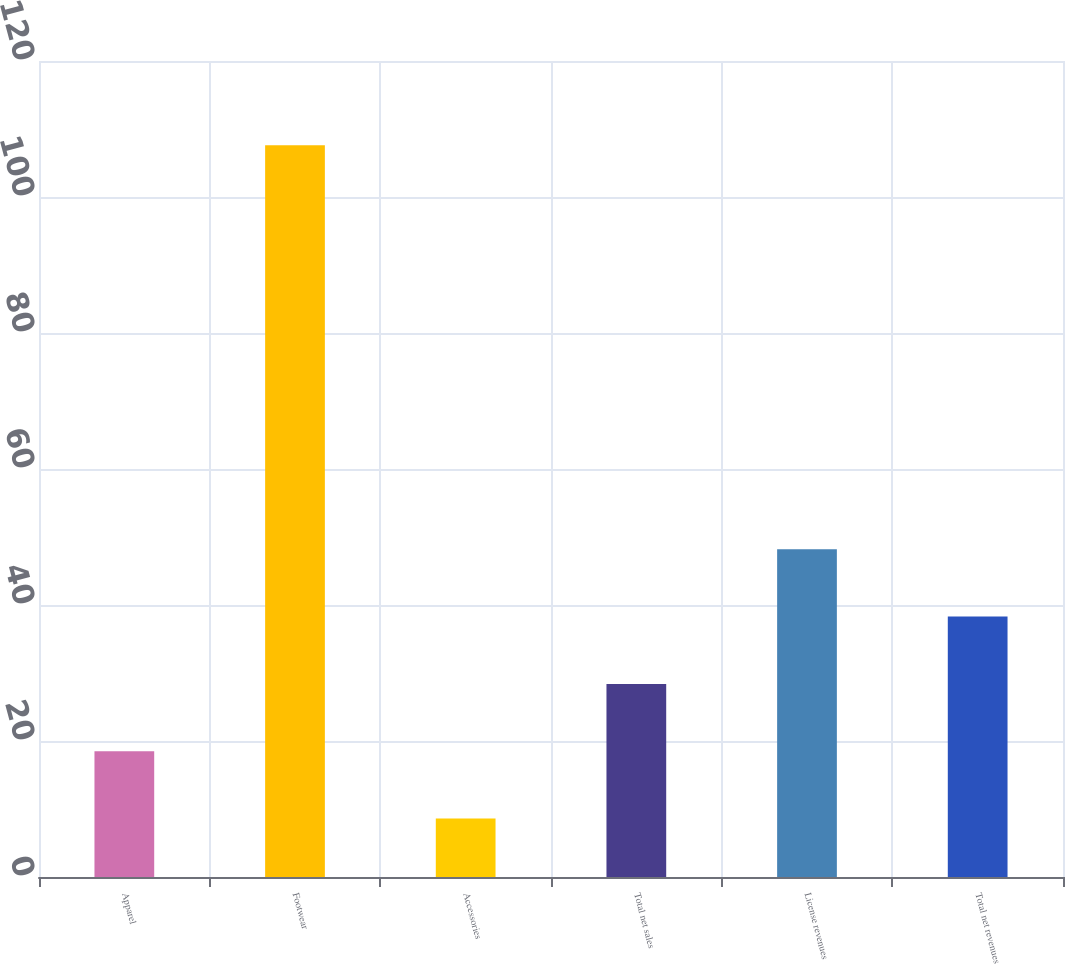Convert chart. <chart><loc_0><loc_0><loc_500><loc_500><bar_chart><fcel>Apparel<fcel>Footwear<fcel>Accessories<fcel>Total net sales<fcel>License revenues<fcel>Total net revenues<nl><fcel>18.5<fcel>107.6<fcel>8.6<fcel>28.4<fcel>48.2<fcel>38.3<nl></chart> 